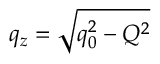<formula> <loc_0><loc_0><loc_500><loc_500>q _ { z } = \sqrt { q _ { 0 } ^ { 2 } - Q ^ { 2 } }</formula> 